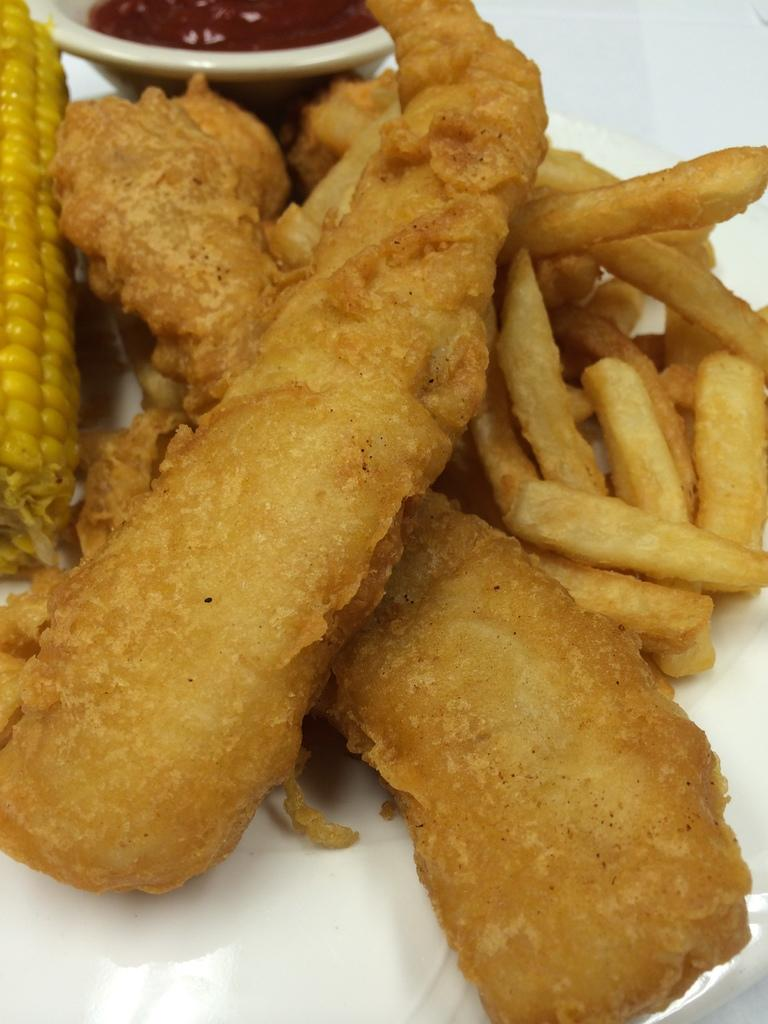What type of food is shown in the image? There are fried snacks in the image. What is the fried snacks placed on? The fried snacks are on a white-colored tissue. Can you identify any specific ingredient in the image? Yes, there is a part of maize visible in the image. What accompaniment is provided for the fried snacks? There is a small bowl with sauce in the image. What type of brick can be seen in the image? There is no brick present in the image. Is there a boy eating the fried snacks in the image? There is no boy present in the image; it only shows the fried snacks, white-colored tissue, maize, and the small bowl with sauce. 